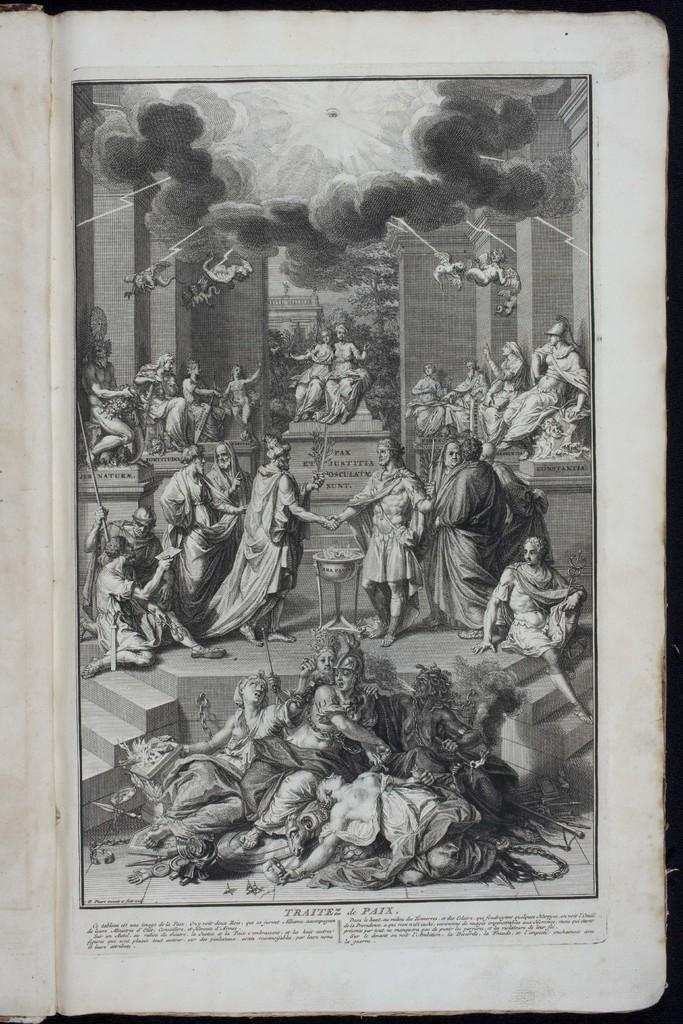What can be seen in the image related to people? There are depictions of persons with costumes in the image. What is written or displayed at the bottom of the image? There is text at the bottom of the image. What is visible at the top of the image? There is smoke visible at the top of the image. What type of plants can be seen growing in the base of the image? There is no base or plants present in the image. 